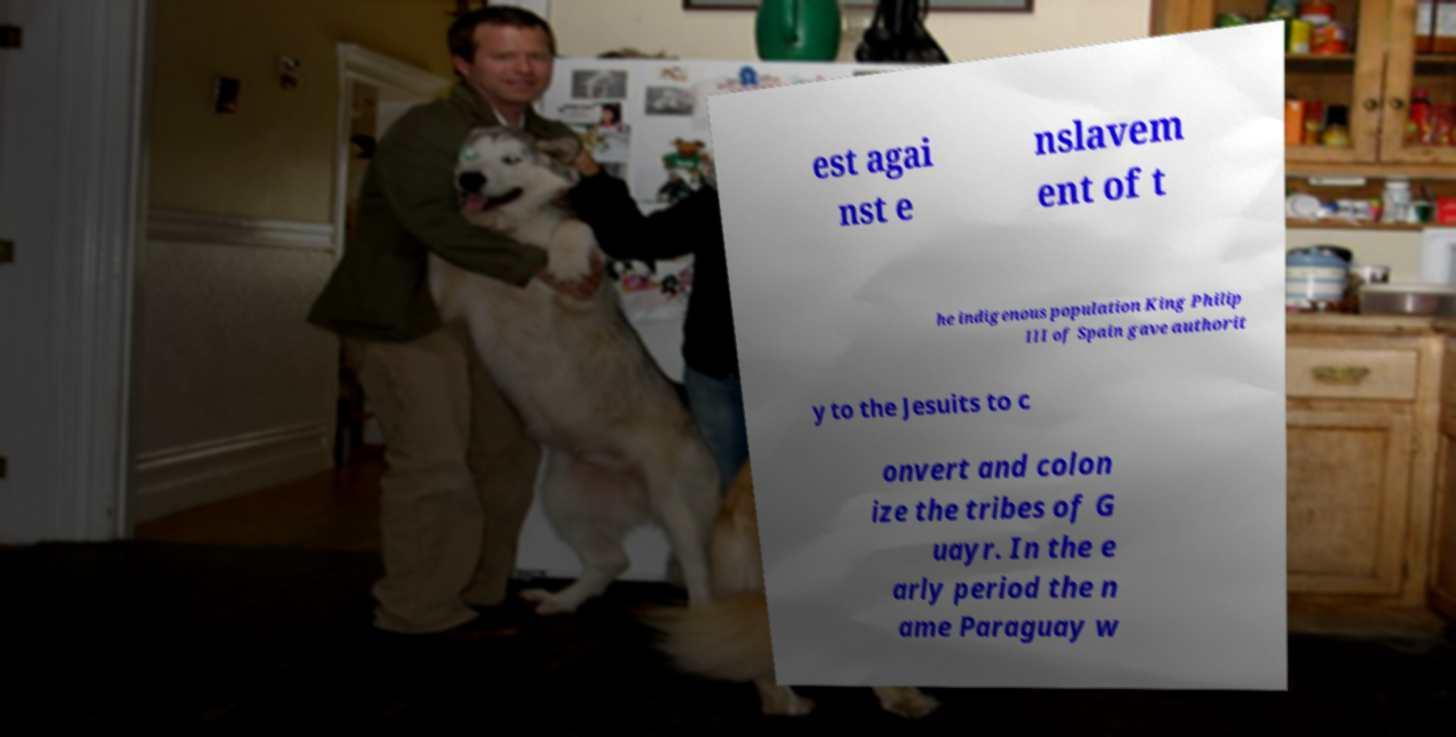For documentation purposes, I need the text within this image transcribed. Could you provide that? est agai nst e nslavem ent of t he indigenous population King Philip III of Spain gave authorit y to the Jesuits to c onvert and colon ize the tribes of G uayr. In the e arly period the n ame Paraguay w 